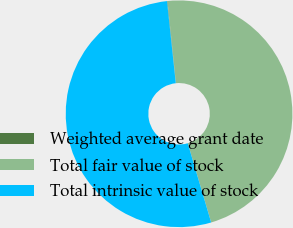Convert chart to OTSL. <chart><loc_0><loc_0><loc_500><loc_500><pie_chart><fcel>Weighted average grant date<fcel>Total fair value of stock<fcel>Total intrinsic value of stock<nl><fcel>0.07%<fcel>47.06%<fcel>52.87%<nl></chart> 